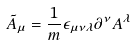<formula> <loc_0><loc_0><loc_500><loc_500>{ \tilde { A } } _ { \mu } = \frac { 1 } { m } \epsilon _ { \mu \nu \lambda } \partial ^ { \nu } { A } ^ { \lambda }</formula> 